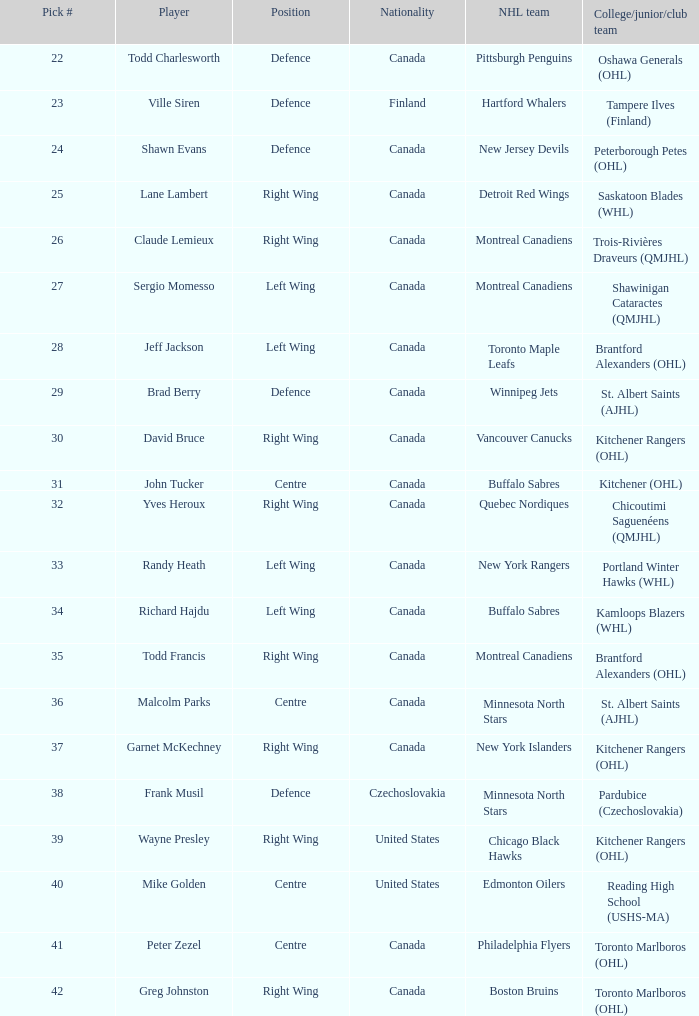How frequently does the nhl team winnipeg jets occur? 1.0. 